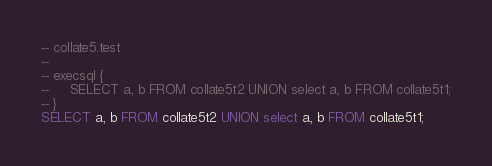Convert code to text. <code><loc_0><loc_0><loc_500><loc_500><_SQL_>-- collate5.test
-- 
-- execsql {
--     SELECT a, b FROM collate5t2 UNION select a, b FROM collate5t1;
-- }
SELECT a, b FROM collate5t2 UNION select a, b FROM collate5t1;</code> 